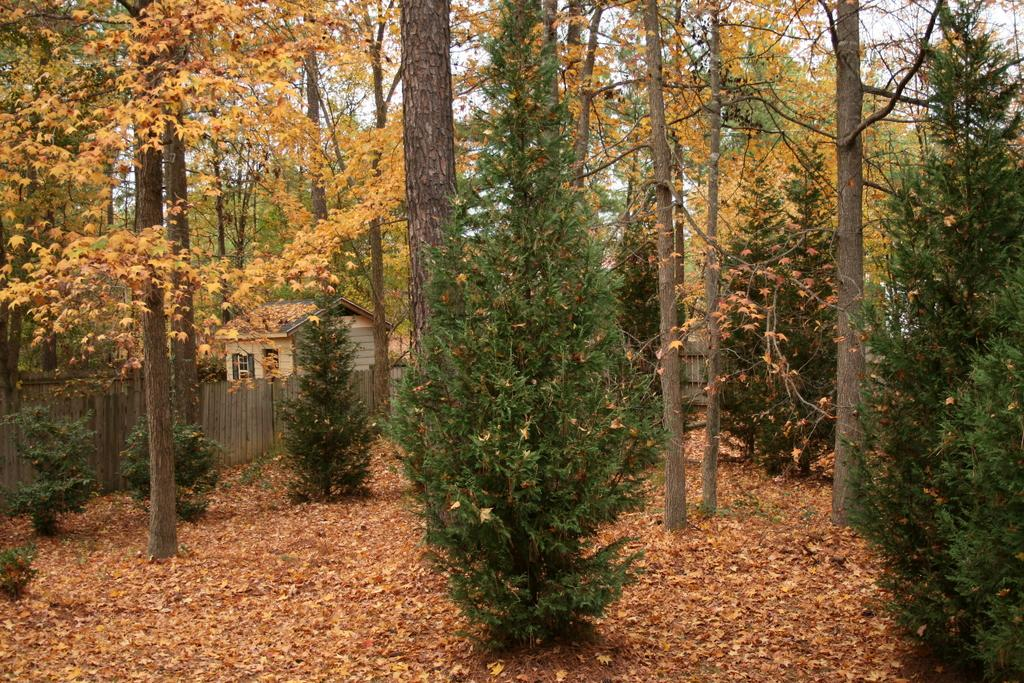What type of vegetation can be seen in the image? There are trees in the image. What is on the ground beneath the trees? Leaves are present on the ground. What can be seen in the background of the image? There is wooden fencing and a house in the background. What part of the natural environment is visible in the image? The sky is visible in the background. Where is the basin located in the image? There is no basin present in the image. What type of bait is being used by the ants in the image? There are no ants present in the image. 